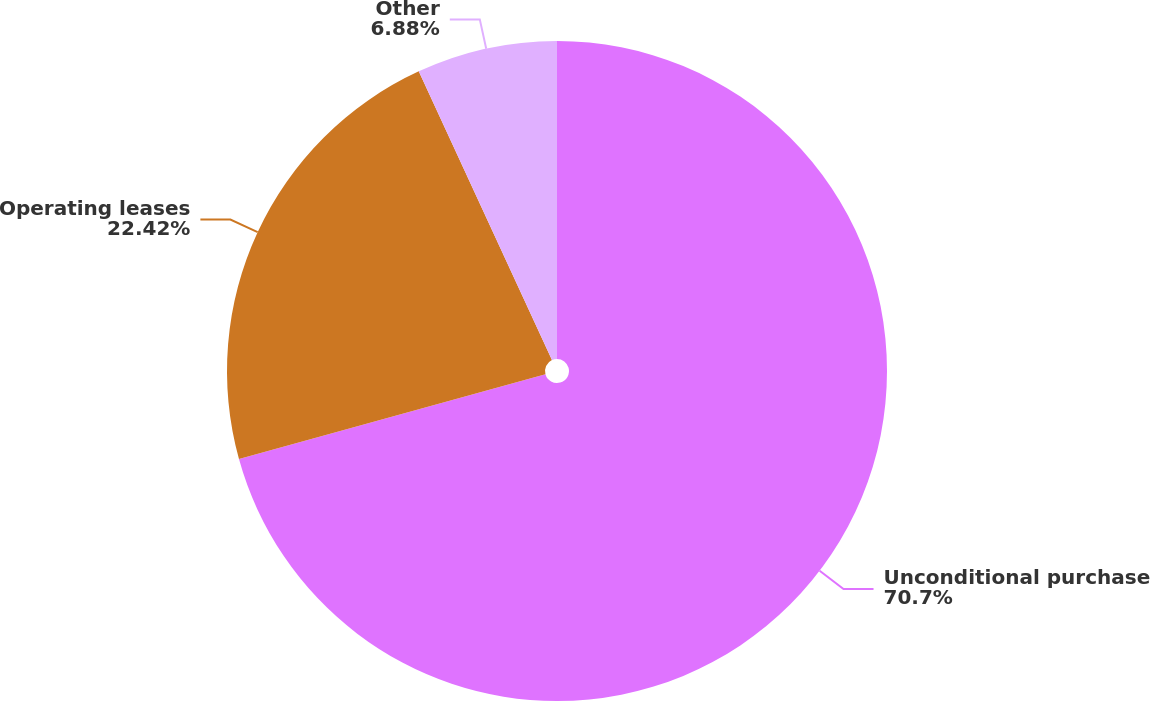Convert chart to OTSL. <chart><loc_0><loc_0><loc_500><loc_500><pie_chart><fcel>Unconditional purchase<fcel>Operating leases<fcel>Other<nl><fcel>70.7%<fcel>22.42%<fcel>6.88%<nl></chart> 